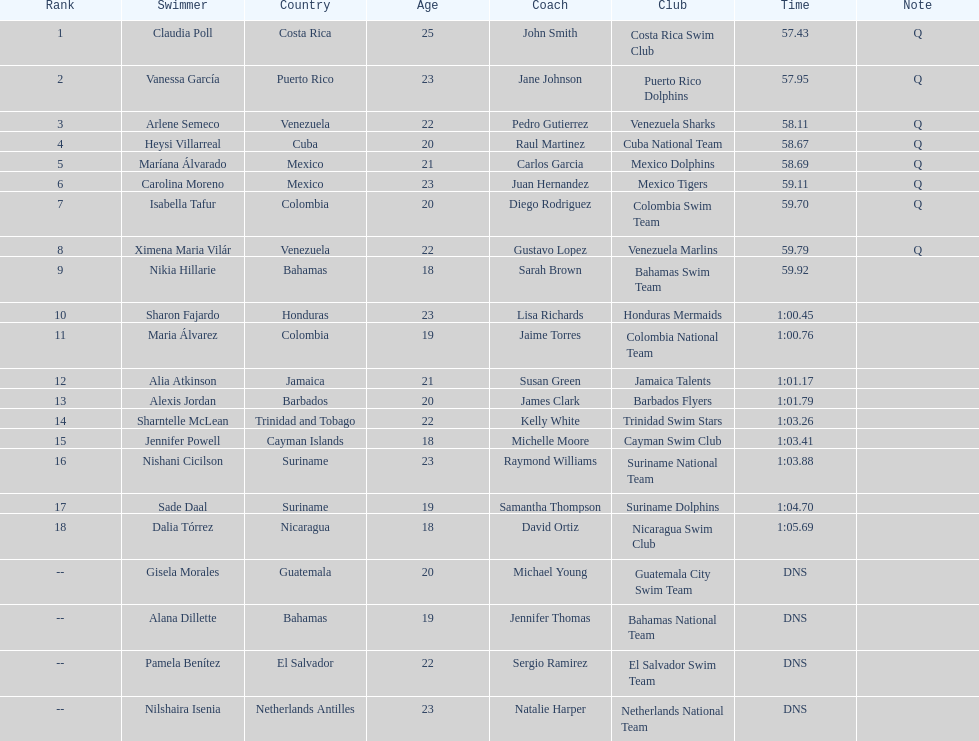Could you parse the entire table as a dict? {'header': ['Rank', 'Swimmer', 'Country', 'Age', 'Coach', 'Club', 'Time', 'Note'], 'rows': [['1', 'Claudia Poll', 'Costa Rica', '25', 'John Smith', 'Costa Rica Swim Club', '57.43', 'Q'], ['2', 'Vanessa García', 'Puerto Rico', '23', 'Jane Johnson', 'Puerto Rico Dolphins', '57.95', 'Q'], ['3', 'Arlene Semeco', 'Venezuela', '22', 'Pedro Gutierrez', 'Venezuela Sharks', '58.11', 'Q'], ['4', 'Heysi Villarreal', 'Cuba', '20', 'Raul Martinez', 'Cuba National Team', '58.67', 'Q'], ['5', 'Maríana Álvarado', 'Mexico', '21', 'Carlos Garcia', 'Mexico Dolphins', '58.69', 'Q'], ['6', 'Carolina Moreno', 'Mexico', '23', 'Juan Hernandez', 'Mexico Tigers', '59.11', 'Q'], ['7', 'Isabella Tafur', 'Colombia', '20', 'Diego Rodriguez', 'Colombia Swim Team', '59.70', 'Q'], ['8', 'Ximena Maria Vilár', 'Venezuela', '22', 'Gustavo Lopez', 'Venezuela Marlins', '59.79', 'Q'], ['9', 'Nikia Hillarie', 'Bahamas', '18', 'Sarah Brown', 'Bahamas Swim Team', '59.92', ''], ['10', 'Sharon Fajardo', 'Honduras', '23', 'Lisa Richards', 'Honduras Mermaids', '1:00.45', ''], ['11', 'Maria Álvarez', 'Colombia', '19', 'Jaime Torres', 'Colombia National Team', '1:00.76', ''], ['12', 'Alia Atkinson', 'Jamaica', '21', 'Susan Green', 'Jamaica Talents', '1:01.17', ''], ['13', 'Alexis Jordan', 'Barbados', '20', 'James Clark', 'Barbados Flyers', '1:01.79', ''], ['14', 'Sharntelle McLean', 'Trinidad and Tobago', '22', 'Kelly White', 'Trinidad Swim Stars', '1:03.26', ''], ['15', 'Jennifer Powell', 'Cayman Islands', '18', 'Michelle Moore', 'Cayman Swim Club', '1:03.41', ''], ['16', 'Nishani Cicilson', 'Suriname', '23', 'Raymond Williams', 'Suriname National Team', '1:03.88', ''], ['17', 'Sade Daal', 'Suriname', '19', 'Samantha Thompson', 'Suriname Dolphins', '1:04.70', ''], ['18', 'Dalia Tórrez', 'Nicaragua', '18', 'David Ortiz', 'Nicaragua Swim Club', '1:05.69', ''], ['--', 'Gisela Morales', 'Guatemala', '20', 'Michael Young', 'Guatemala City Swim Team', 'DNS', ''], ['--', 'Alana Dillette', 'Bahamas', '19', 'Jennifer Thomas', 'Bahamas National Team', 'DNS', ''], ['--', 'Pamela Benítez', 'El Salvador', '22', 'Sergio Ramirez', 'El Salvador Swim Team', 'DNS', ''], ['--', 'Nilshaira Isenia', 'Netherlands Antilles', '23', 'Natalie Harper', 'Netherlands National Team', 'DNS', '']]} Which swimmer had the longest time? Dalia Tórrez. 